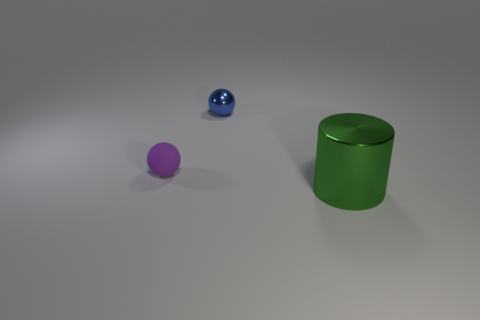Are there more rubber objects that are on the left side of the blue metallic sphere than tiny red matte cylinders? There are neither rubber objects on the left side of the blue metallic sphere nor tiny red matte cylinders present in the image, so the comparison cannot be made. The image actually includes a blue metallic sphere, a purple rubber sphere, and a green metallic cylinder. 